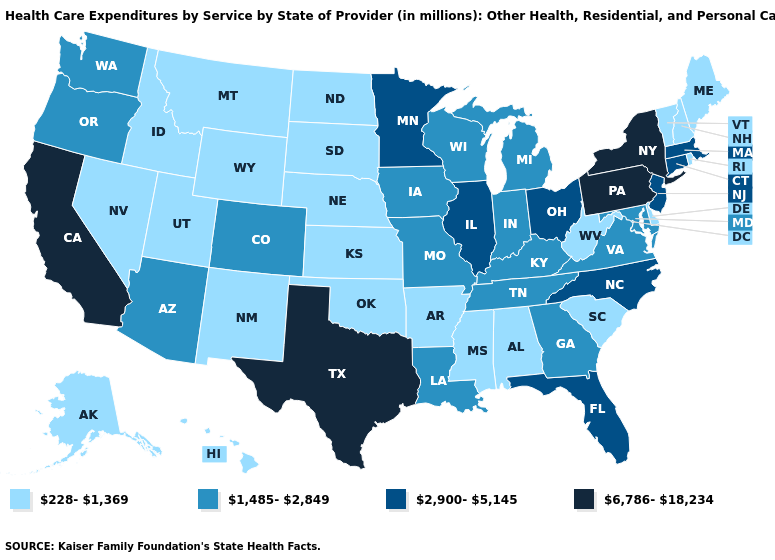Among the states that border Maryland , which have the highest value?
Short answer required. Pennsylvania. Name the states that have a value in the range 6,786-18,234?
Write a very short answer. California, New York, Pennsylvania, Texas. Does the map have missing data?
Answer briefly. No. What is the value of Delaware?
Keep it brief. 228-1,369. Name the states that have a value in the range 1,485-2,849?
Give a very brief answer. Arizona, Colorado, Georgia, Indiana, Iowa, Kentucky, Louisiana, Maryland, Michigan, Missouri, Oregon, Tennessee, Virginia, Washington, Wisconsin. Name the states that have a value in the range 6,786-18,234?
Short answer required. California, New York, Pennsylvania, Texas. What is the value of Hawaii?
Concise answer only. 228-1,369. Which states have the lowest value in the USA?
Keep it brief. Alabama, Alaska, Arkansas, Delaware, Hawaii, Idaho, Kansas, Maine, Mississippi, Montana, Nebraska, Nevada, New Hampshire, New Mexico, North Dakota, Oklahoma, Rhode Island, South Carolina, South Dakota, Utah, Vermont, West Virginia, Wyoming. What is the lowest value in the USA?
Quick response, please. 228-1,369. Name the states that have a value in the range 2,900-5,145?
Concise answer only. Connecticut, Florida, Illinois, Massachusetts, Minnesota, New Jersey, North Carolina, Ohio. What is the value of Nevada?
Answer briefly. 228-1,369. Among the states that border Ohio , does Michigan have the lowest value?
Concise answer only. No. Does Rhode Island have the highest value in the Northeast?
Be succinct. No. How many symbols are there in the legend?
Concise answer only. 4. What is the value of Wisconsin?
Concise answer only. 1,485-2,849. 